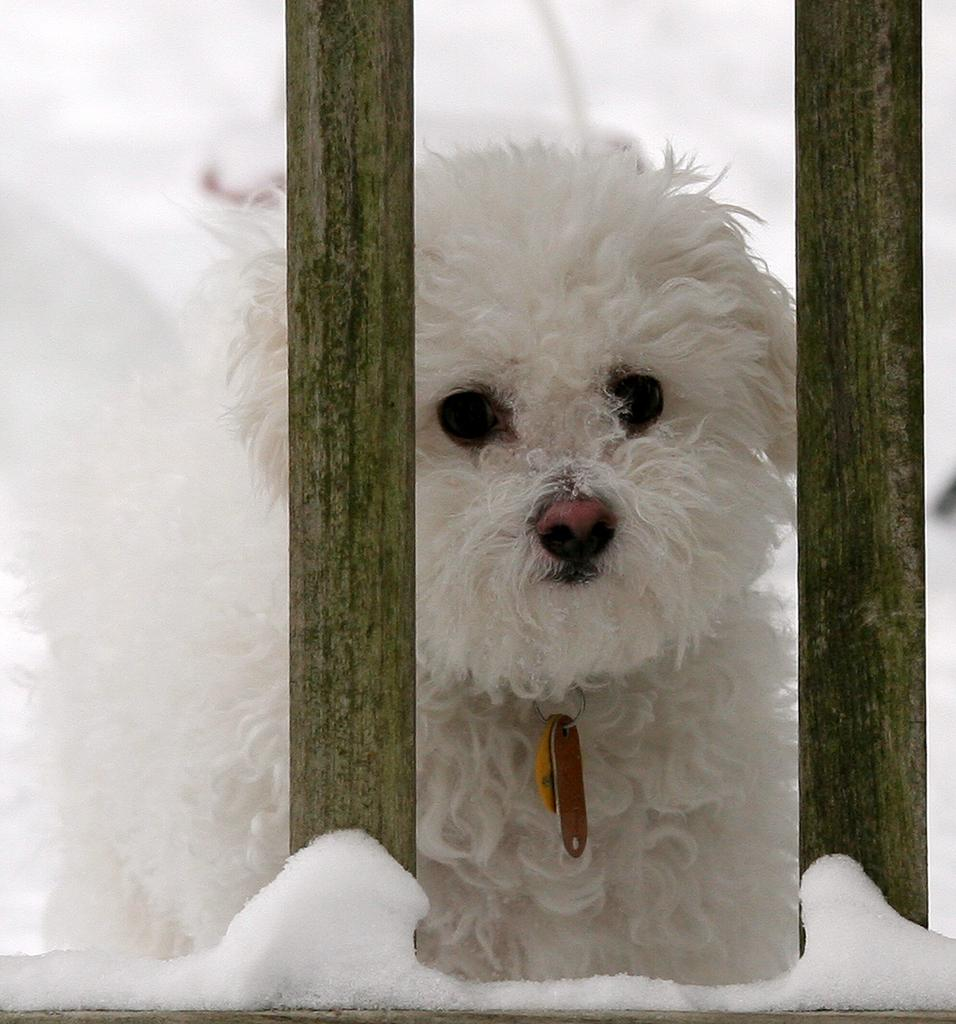What type of animal is in the image? There is a dog in the image. Where is the dog located in relation to other objects? The dog is beside wooden poles. What type of weather or season is suggested by the image? The presence of snow visible at the bottom of the image suggests a cold or wintery setting. What flavor of ice cream does the dog prefer in the image? There is no ice cream present in the image, and therefore no indication of the dog's ice cream preference. 